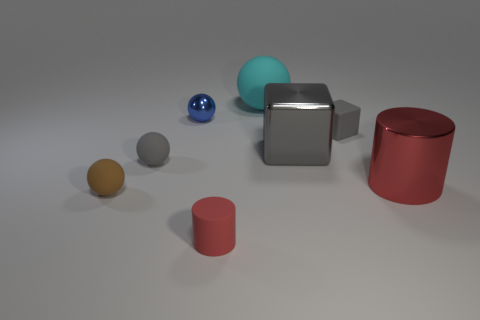What number of gray objects are either things or tiny cylinders?
Make the answer very short. 3. There is a gray cube that is the same material as the tiny gray sphere; what size is it?
Your answer should be very brief. Small. Is the material of the red cylinder behind the tiny brown matte object the same as the gray block that is behind the big gray metallic block?
Provide a short and direct response. No. What number of cylinders are large red metallic objects or blue metallic objects?
Provide a short and direct response. 1. There is a tiny gray rubber thing to the right of the red object in front of the big red object; how many tiny brown matte spheres are in front of it?
Provide a short and direct response. 1. There is a small blue thing that is the same shape as the cyan thing; what material is it?
Your answer should be very brief. Metal. Are there any other things that are the same material as the brown object?
Keep it short and to the point. Yes. What is the color of the matte thing that is behind the tiny blue metallic ball?
Your answer should be very brief. Cyan. Do the small brown thing and the red thing that is to the left of the large ball have the same material?
Make the answer very short. Yes. What is the material of the small cylinder?
Ensure brevity in your answer.  Rubber. 